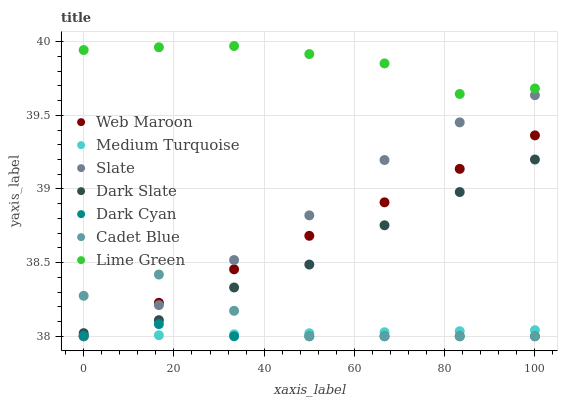Does Dark Cyan have the minimum area under the curve?
Answer yes or no. Yes. Does Lime Green have the maximum area under the curve?
Answer yes or no. Yes. Does Slate have the minimum area under the curve?
Answer yes or no. No. Does Slate have the maximum area under the curve?
Answer yes or no. No. Is Web Maroon the smoothest?
Answer yes or no. Yes. Is Cadet Blue the roughest?
Answer yes or no. Yes. Is Slate the smoothest?
Answer yes or no. No. Is Slate the roughest?
Answer yes or no. No. Does Cadet Blue have the lowest value?
Answer yes or no. Yes. Does Dark Slate have the lowest value?
Answer yes or no. No. Does Lime Green have the highest value?
Answer yes or no. Yes. Does Slate have the highest value?
Answer yes or no. No. Is Cadet Blue less than Lime Green?
Answer yes or no. Yes. Is Lime Green greater than Cadet Blue?
Answer yes or no. Yes. Does Dark Cyan intersect Web Maroon?
Answer yes or no. Yes. Is Dark Cyan less than Web Maroon?
Answer yes or no. No. Is Dark Cyan greater than Web Maroon?
Answer yes or no. No. Does Cadet Blue intersect Lime Green?
Answer yes or no. No. 